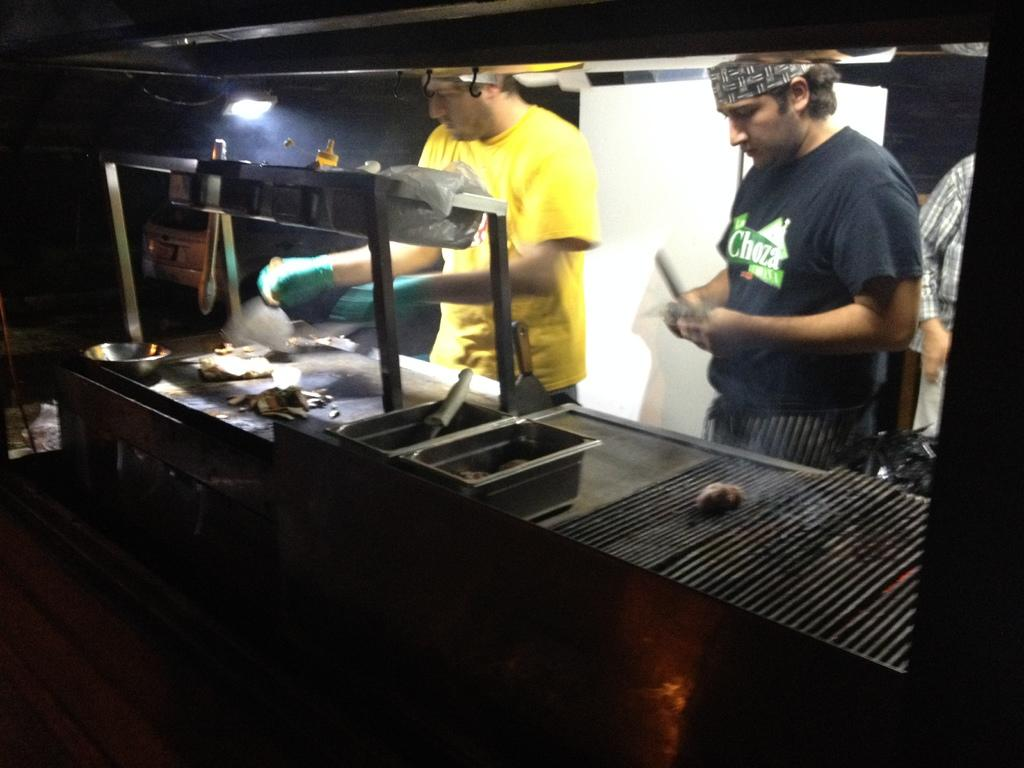How many people are in the image? There are 2 people in the image. What are the people doing in the image? The people are standing and cooking. Can you describe the clothing of one of the people? One person is wearing a yellow t-shirt. What is the source of light in the image? There is a light on the top of the image. How are the people sorting the celery in the image? There is no celery present in the image, so it cannot be sorted. Where is the faucet located in the image? There is no faucet present in the image. 